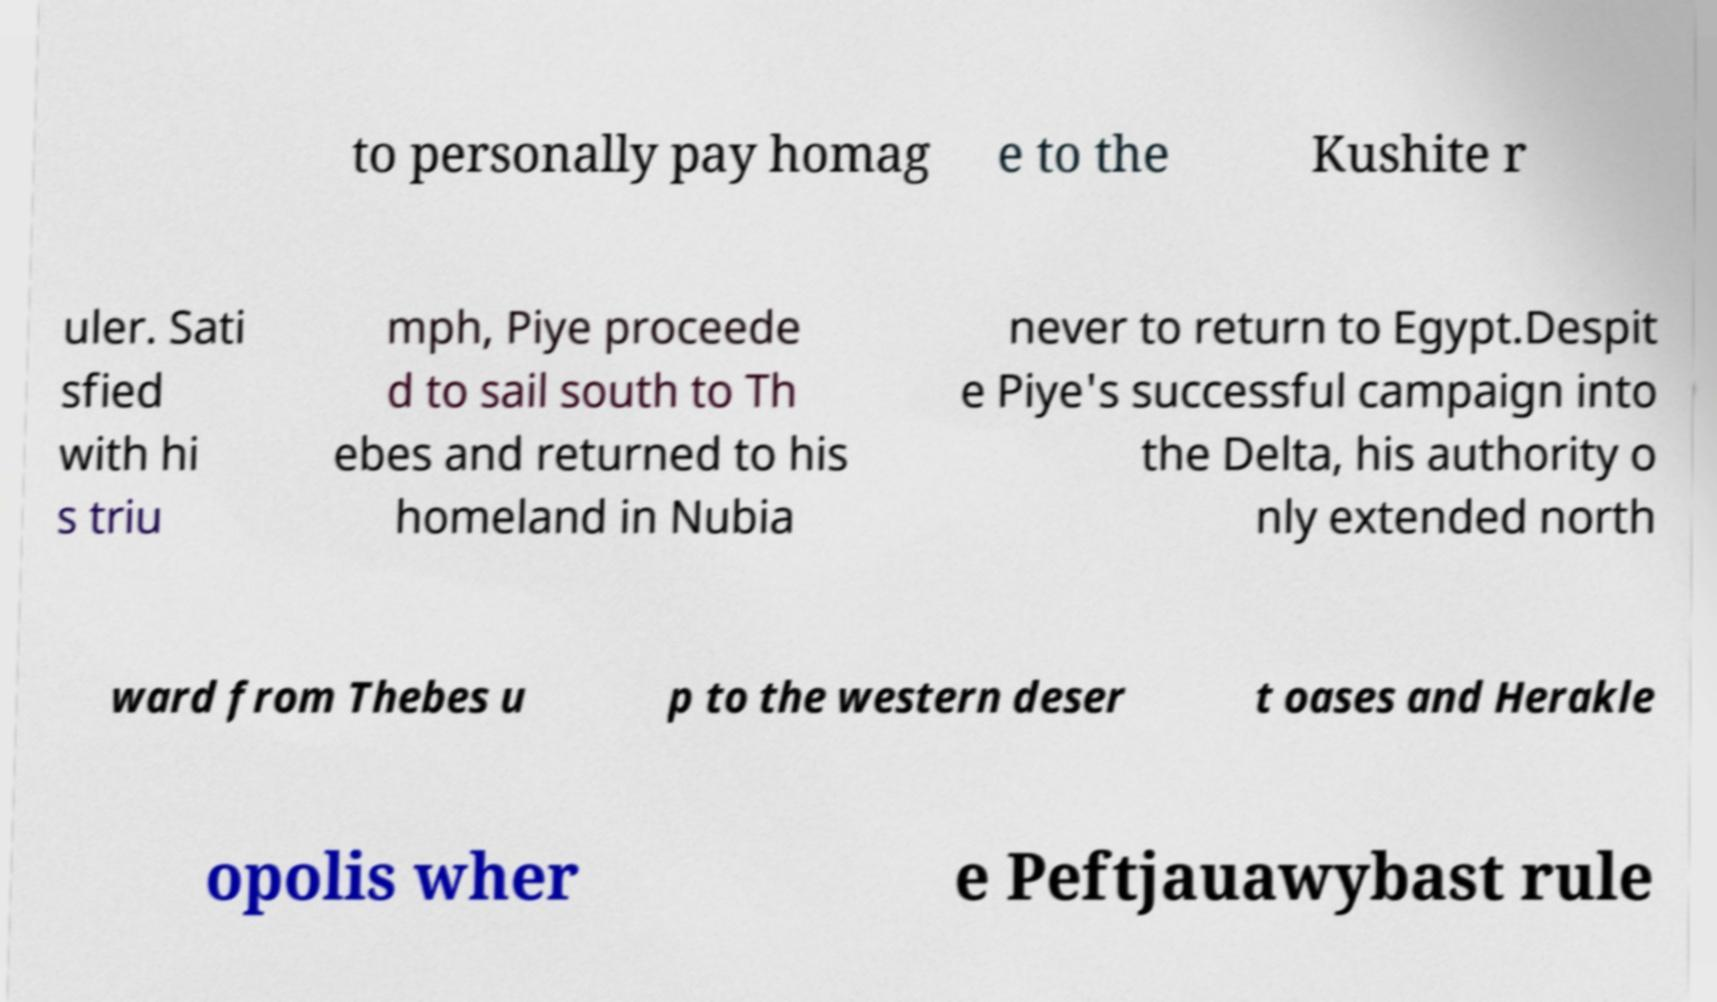Could you assist in decoding the text presented in this image and type it out clearly? to personally pay homag e to the Kushite r uler. Sati sfied with hi s triu mph, Piye proceede d to sail south to Th ebes and returned to his homeland in Nubia never to return to Egypt.Despit e Piye's successful campaign into the Delta, his authority o nly extended north ward from Thebes u p to the western deser t oases and Herakle opolis wher e Peftjauawybast rule 